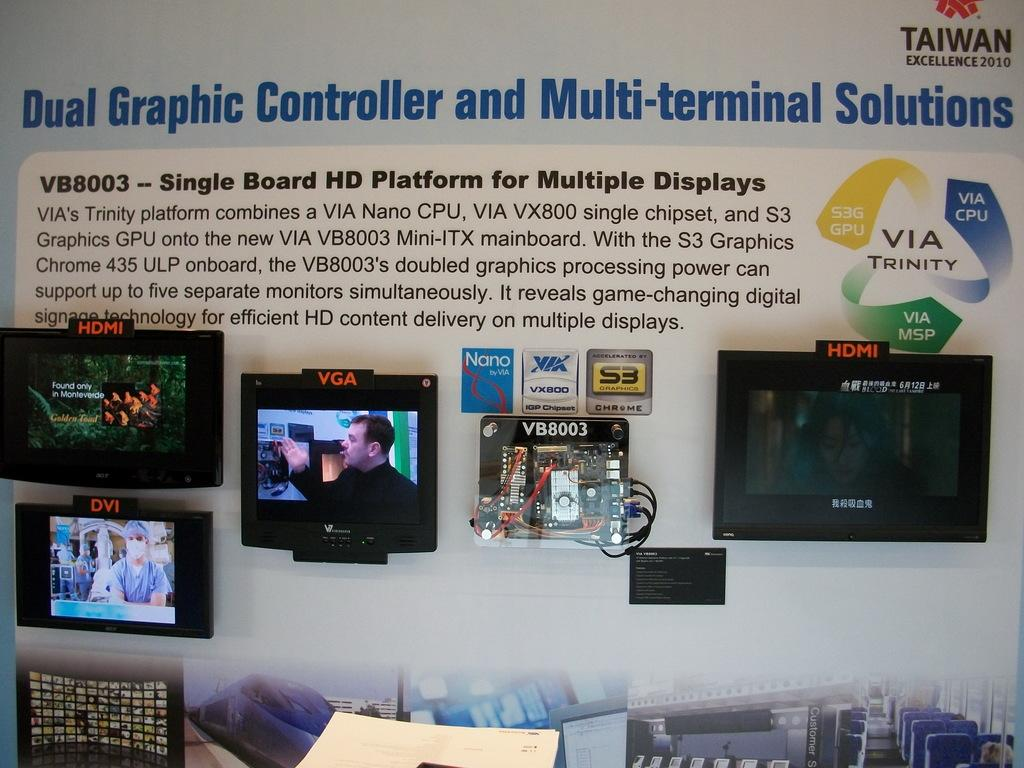<image>
Give a short and clear explanation of the subsequent image. Some monitors with the words Dual Graphic Controller and Multi-terminal Soultions above them. 